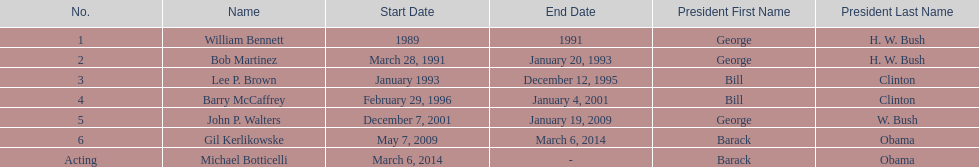How long did bob martinez serve as director? 2 years. 